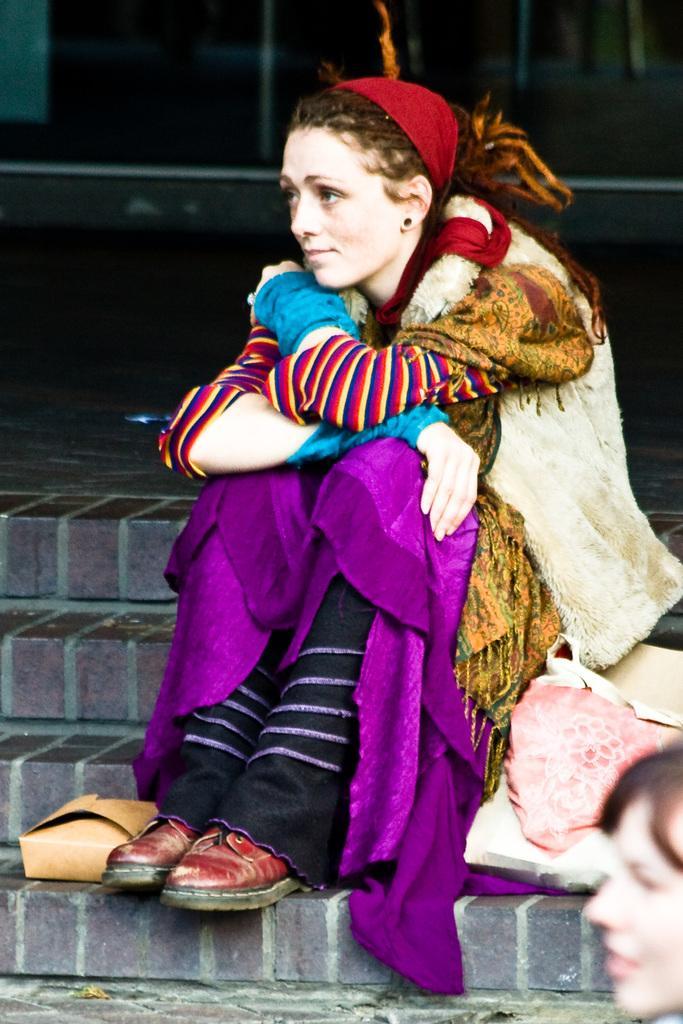Please provide a concise description of this image. In this image, we can see a woman is sitting on the stairs. Here we can see some objects, box. At the bottom of the image, we can see surface. Right side bottom corner, we can see a human face. In the background we can see few objects. 